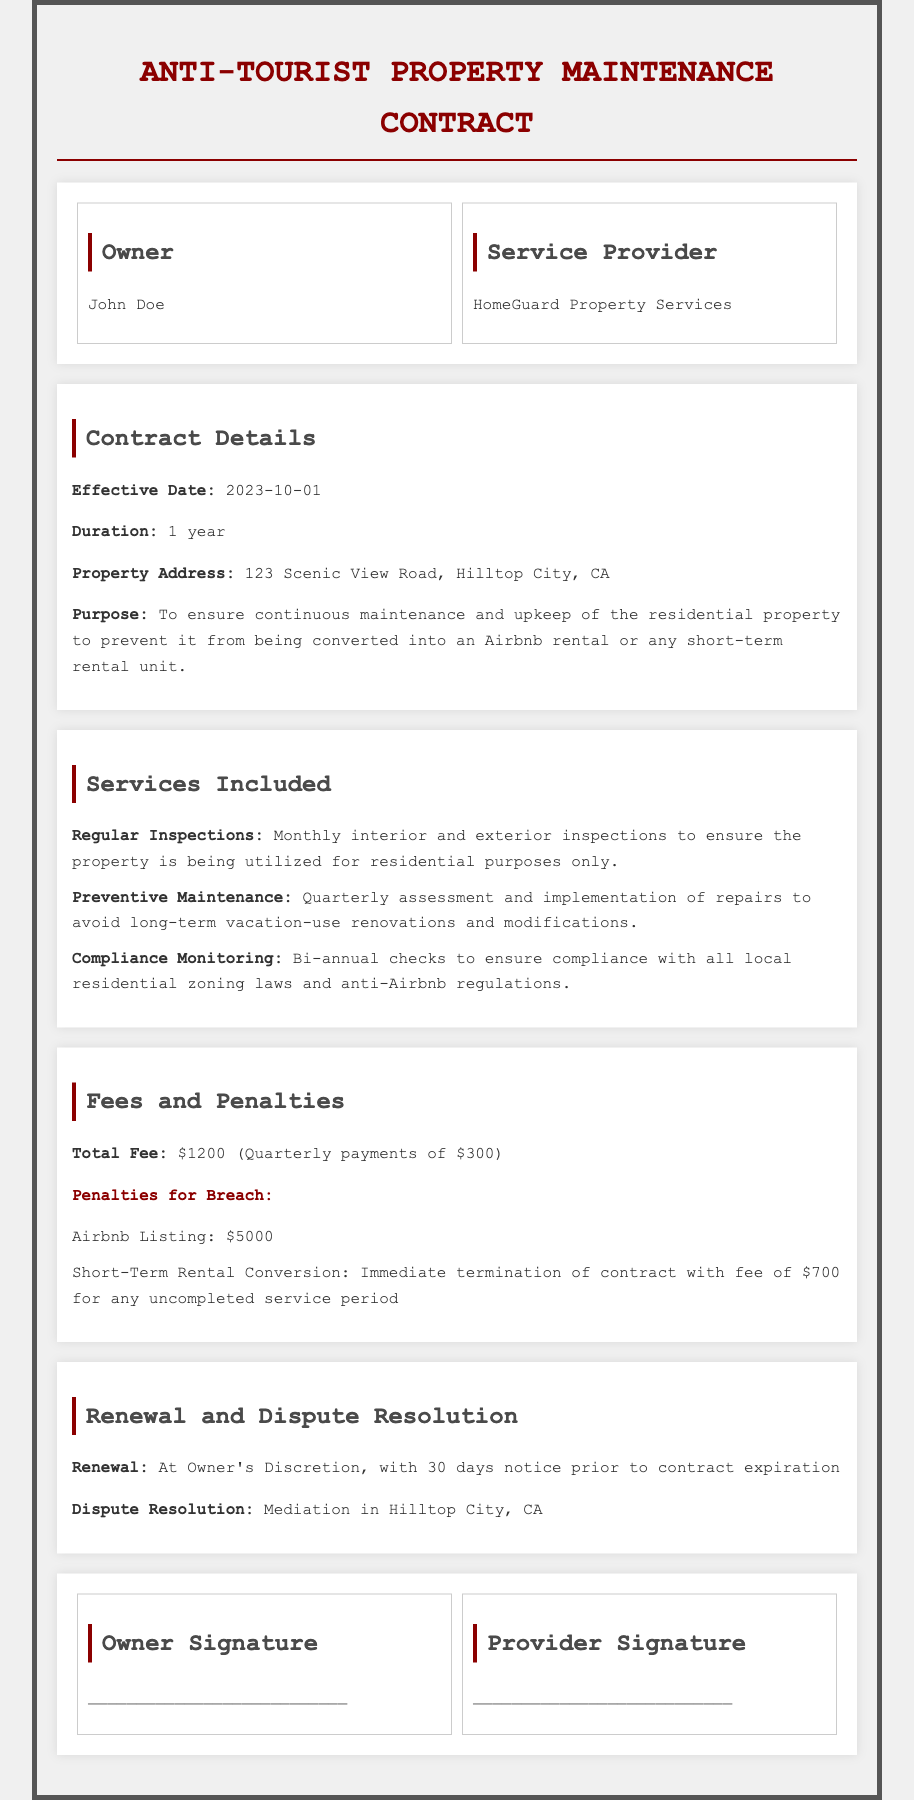What is the effective date of the contract? The effective date of the contract is specified in the document as 2023-10-01.
Answer: 2023-10-01 What is the total fee for the services? The total fee for the services is explicitly stated in the document as $1200.
Answer: $1200 Who is the service provider? The service provider’s name is mentioned in the document as HomeGuard Property Services.
Answer: HomeGuard Property Services How long is the duration of the contract? The duration of the contract is specified in the document and is one year.
Answer: 1 year What is the penalty for an Airbnb listing? The document details a specific penalty for an Airbnb listing as $5000.
Answer: $5000 What type of checks are performed bi-annually? The checks performed bi-annually are for compliance monitoring with local residential zoning laws.
Answer: Compliance Monitoring What requires a 30 days notice? The document states that a 30 days notice is required for contract renewal at the owner's discretion.
Answer: Contract Renewal What happens if the property is converted to a short-term rental? The result of the property being converted to a short-term rental is the immediate termination of the contract.
Answer: Immediate termination Where is the dispute resolution to take place? The document specifies that mediation for dispute resolution takes place in Hilltop City, CA.
Answer: Hilltop City, CA 